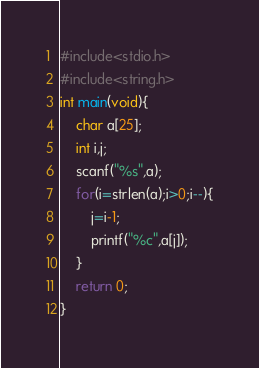<code> <loc_0><loc_0><loc_500><loc_500><_C_>#include<stdio.h>
#include<string.h>
int main(void){
    char a[25];
    int i,j;
    scanf("%s",a);
    for(i=strlen(a);i>0;i--){
        j=i-1;
        printf("%c",a[j]);
    }
    return 0;
}</code> 